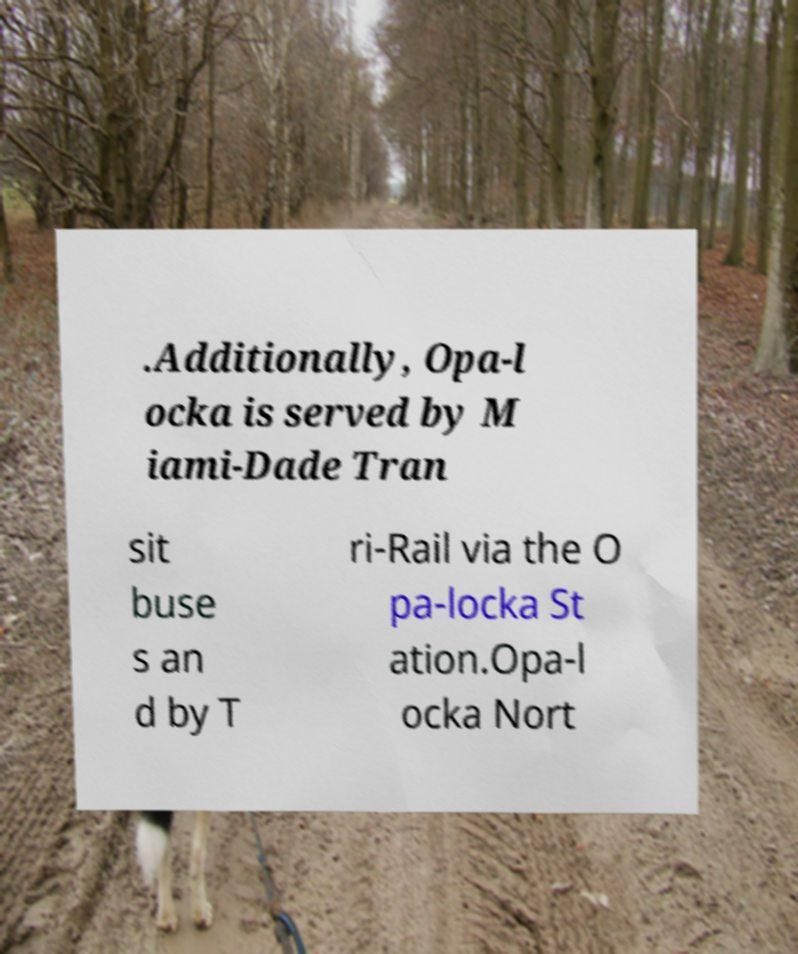Please identify and transcribe the text found in this image. .Additionally, Opa-l ocka is served by M iami-Dade Tran sit buse s an d by T ri-Rail via the O pa-locka St ation.Opa-l ocka Nort 